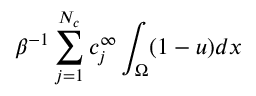<formula> <loc_0><loc_0><loc_500><loc_500>\beta ^ { - 1 } \sum _ { j = 1 } ^ { N _ { c } } c _ { j } ^ { \infty } \int _ { \Omega } ( 1 - u ) d x</formula> 